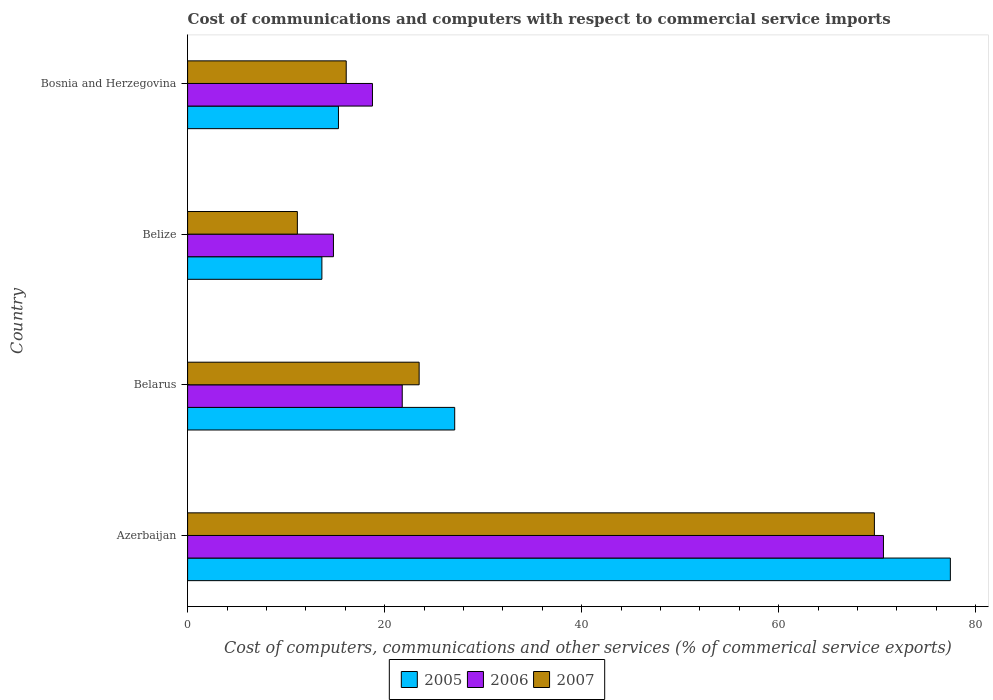How many groups of bars are there?
Give a very brief answer. 4. Are the number of bars on each tick of the Y-axis equal?
Your answer should be compact. Yes. How many bars are there on the 3rd tick from the top?
Provide a short and direct response. 3. How many bars are there on the 4th tick from the bottom?
Make the answer very short. 3. What is the label of the 2nd group of bars from the top?
Give a very brief answer. Belize. In how many cases, is the number of bars for a given country not equal to the number of legend labels?
Offer a very short reply. 0. What is the cost of communications and computers in 2007 in Bosnia and Herzegovina?
Your answer should be compact. 16.1. Across all countries, what is the maximum cost of communications and computers in 2007?
Provide a short and direct response. 69.72. Across all countries, what is the minimum cost of communications and computers in 2005?
Your answer should be very brief. 13.63. In which country was the cost of communications and computers in 2006 maximum?
Provide a short and direct response. Azerbaijan. In which country was the cost of communications and computers in 2005 minimum?
Ensure brevity in your answer.  Belize. What is the total cost of communications and computers in 2007 in the graph?
Provide a succinct answer. 120.46. What is the difference between the cost of communications and computers in 2006 in Belize and that in Bosnia and Herzegovina?
Provide a succinct answer. -3.96. What is the difference between the cost of communications and computers in 2007 in Belize and the cost of communications and computers in 2006 in Belarus?
Provide a succinct answer. -10.65. What is the average cost of communications and computers in 2007 per country?
Your answer should be compact. 30.12. What is the difference between the cost of communications and computers in 2005 and cost of communications and computers in 2006 in Azerbaijan?
Provide a short and direct response. 6.79. In how many countries, is the cost of communications and computers in 2005 greater than 36 %?
Keep it short and to the point. 1. What is the ratio of the cost of communications and computers in 2005 in Azerbaijan to that in Belarus?
Your answer should be compact. 2.86. Is the cost of communications and computers in 2007 in Azerbaijan less than that in Bosnia and Herzegovina?
Provide a succinct answer. No. Is the difference between the cost of communications and computers in 2005 in Belarus and Belize greater than the difference between the cost of communications and computers in 2006 in Belarus and Belize?
Make the answer very short. Yes. What is the difference between the highest and the second highest cost of communications and computers in 2005?
Ensure brevity in your answer.  50.31. What is the difference between the highest and the lowest cost of communications and computers in 2005?
Offer a terse response. 63.8. In how many countries, is the cost of communications and computers in 2005 greater than the average cost of communications and computers in 2005 taken over all countries?
Your response must be concise. 1. Is the sum of the cost of communications and computers in 2006 in Belize and Bosnia and Herzegovina greater than the maximum cost of communications and computers in 2007 across all countries?
Provide a short and direct response. No. What does the 3rd bar from the bottom in Azerbaijan represents?
Provide a short and direct response. 2007. Is it the case that in every country, the sum of the cost of communications and computers in 2005 and cost of communications and computers in 2006 is greater than the cost of communications and computers in 2007?
Provide a succinct answer. Yes. How many bars are there?
Your answer should be very brief. 12. Are the values on the major ticks of X-axis written in scientific E-notation?
Make the answer very short. No. Does the graph contain any zero values?
Ensure brevity in your answer.  No. Does the graph contain grids?
Your answer should be very brief. No. Where does the legend appear in the graph?
Give a very brief answer. Bottom center. What is the title of the graph?
Ensure brevity in your answer.  Cost of communications and computers with respect to commercial service imports. Does "2009" appear as one of the legend labels in the graph?
Give a very brief answer. No. What is the label or title of the X-axis?
Provide a short and direct response. Cost of computers, communications and other services (% of commerical service exports). What is the Cost of computers, communications and other services (% of commerical service exports) in 2005 in Azerbaijan?
Keep it short and to the point. 77.43. What is the Cost of computers, communications and other services (% of commerical service exports) in 2006 in Azerbaijan?
Your response must be concise. 70.64. What is the Cost of computers, communications and other services (% of commerical service exports) in 2007 in Azerbaijan?
Make the answer very short. 69.72. What is the Cost of computers, communications and other services (% of commerical service exports) in 2005 in Belarus?
Offer a very short reply. 27.11. What is the Cost of computers, communications and other services (% of commerical service exports) of 2006 in Belarus?
Your answer should be very brief. 21.79. What is the Cost of computers, communications and other services (% of commerical service exports) in 2007 in Belarus?
Ensure brevity in your answer.  23.5. What is the Cost of computers, communications and other services (% of commerical service exports) in 2005 in Belize?
Offer a terse response. 13.63. What is the Cost of computers, communications and other services (% of commerical service exports) of 2006 in Belize?
Offer a very short reply. 14.8. What is the Cost of computers, communications and other services (% of commerical service exports) of 2007 in Belize?
Your response must be concise. 11.14. What is the Cost of computers, communications and other services (% of commerical service exports) of 2005 in Bosnia and Herzegovina?
Keep it short and to the point. 15.31. What is the Cost of computers, communications and other services (% of commerical service exports) of 2006 in Bosnia and Herzegovina?
Ensure brevity in your answer.  18.76. What is the Cost of computers, communications and other services (% of commerical service exports) of 2007 in Bosnia and Herzegovina?
Give a very brief answer. 16.1. Across all countries, what is the maximum Cost of computers, communications and other services (% of commerical service exports) of 2005?
Keep it short and to the point. 77.43. Across all countries, what is the maximum Cost of computers, communications and other services (% of commerical service exports) of 2006?
Ensure brevity in your answer.  70.64. Across all countries, what is the maximum Cost of computers, communications and other services (% of commerical service exports) of 2007?
Offer a very short reply. 69.72. Across all countries, what is the minimum Cost of computers, communications and other services (% of commerical service exports) of 2005?
Your response must be concise. 13.63. Across all countries, what is the minimum Cost of computers, communications and other services (% of commerical service exports) in 2006?
Give a very brief answer. 14.8. Across all countries, what is the minimum Cost of computers, communications and other services (% of commerical service exports) in 2007?
Ensure brevity in your answer.  11.14. What is the total Cost of computers, communications and other services (% of commerical service exports) in 2005 in the graph?
Offer a very short reply. 133.49. What is the total Cost of computers, communications and other services (% of commerical service exports) in 2006 in the graph?
Offer a terse response. 125.99. What is the total Cost of computers, communications and other services (% of commerical service exports) in 2007 in the graph?
Offer a very short reply. 120.46. What is the difference between the Cost of computers, communications and other services (% of commerical service exports) in 2005 in Azerbaijan and that in Belarus?
Provide a succinct answer. 50.31. What is the difference between the Cost of computers, communications and other services (% of commerical service exports) in 2006 in Azerbaijan and that in Belarus?
Give a very brief answer. 48.85. What is the difference between the Cost of computers, communications and other services (% of commerical service exports) in 2007 in Azerbaijan and that in Belarus?
Make the answer very short. 46.21. What is the difference between the Cost of computers, communications and other services (% of commerical service exports) of 2005 in Azerbaijan and that in Belize?
Provide a short and direct response. 63.8. What is the difference between the Cost of computers, communications and other services (% of commerical service exports) of 2006 in Azerbaijan and that in Belize?
Provide a short and direct response. 55.83. What is the difference between the Cost of computers, communications and other services (% of commerical service exports) of 2007 in Azerbaijan and that in Belize?
Provide a short and direct response. 58.57. What is the difference between the Cost of computers, communications and other services (% of commerical service exports) in 2005 in Azerbaijan and that in Bosnia and Herzegovina?
Your response must be concise. 62.11. What is the difference between the Cost of computers, communications and other services (% of commerical service exports) in 2006 in Azerbaijan and that in Bosnia and Herzegovina?
Give a very brief answer. 51.87. What is the difference between the Cost of computers, communications and other services (% of commerical service exports) in 2007 in Azerbaijan and that in Bosnia and Herzegovina?
Keep it short and to the point. 53.61. What is the difference between the Cost of computers, communications and other services (% of commerical service exports) in 2005 in Belarus and that in Belize?
Provide a short and direct response. 13.48. What is the difference between the Cost of computers, communications and other services (% of commerical service exports) of 2006 in Belarus and that in Belize?
Your response must be concise. 6.98. What is the difference between the Cost of computers, communications and other services (% of commerical service exports) in 2007 in Belarus and that in Belize?
Keep it short and to the point. 12.36. What is the difference between the Cost of computers, communications and other services (% of commerical service exports) of 2005 in Belarus and that in Bosnia and Herzegovina?
Make the answer very short. 11.8. What is the difference between the Cost of computers, communications and other services (% of commerical service exports) of 2006 in Belarus and that in Bosnia and Herzegovina?
Your response must be concise. 3.02. What is the difference between the Cost of computers, communications and other services (% of commerical service exports) in 2007 in Belarus and that in Bosnia and Herzegovina?
Provide a succinct answer. 7.4. What is the difference between the Cost of computers, communications and other services (% of commerical service exports) of 2005 in Belize and that in Bosnia and Herzegovina?
Give a very brief answer. -1.68. What is the difference between the Cost of computers, communications and other services (% of commerical service exports) of 2006 in Belize and that in Bosnia and Herzegovina?
Make the answer very short. -3.96. What is the difference between the Cost of computers, communications and other services (% of commerical service exports) in 2007 in Belize and that in Bosnia and Herzegovina?
Your answer should be very brief. -4.96. What is the difference between the Cost of computers, communications and other services (% of commerical service exports) in 2005 in Azerbaijan and the Cost of computers, communications and other services (% of commerical service exports) in 2006 in Belarus?
Your answer should be compact. 55.64. What is the difference between the Cost of computers, communications and other services (% of commerical service exports) of 2005 in Azerbaijan and the Cost of computers, communications and other services (% of commerical service exports) of 2007 in Belarus?
Keep it short and to the point. 53.92. What is the difference between the Cost of computers, communications and other services (% of commerical service exports) of 2006 in Azerbaijan and the Cost of computers, communications and other services (% of commerical service exports) of 2007 in Belarus?
Your answer should be very brief. 47.13. What is the difference between the Cost of computers, communications and other services (% of commerical service exports) in 2005 in Azerbaijan and the Cost of computers, communications and other services (% of commerical service exports) in 2006 in Belize?
Your answer should be compact. 62.62. What is the difference between the Cost of computers, communications and other services (% of commerical service exports) in 2005 in Azerbaijan and the Cost of computers, communications and other services (% of commerical service exports) in 2007 in Belize?
Ensure brevity in your answer.  66.29. What is the difference between the Cost of computers, communications and other services (% of commerical service exports) of 2006 in Azerbaijan and the Cost of computers, communications and other services (% of commerical service exports) of 2007 in Belize?
Ensure brevity in your answer.  59.49. What is the difference between the Cost of computers, communications and other services (% of commerical service exports) of 2005 in Azerbaijan and the Cost of computers, communications and other services (% of commerical service exports) of 2006 in Bosnia and Herzegovina?
Provide a succinct answer. 58.66. What is the difference between the Cost of computers, communications and other services (% of commerical service exports) in 2005 in Azerbaijan and the Cost of computers, communications and other services (% of commerical service exports) in 2007 in Bosnia and Herzegovina?
Provide a succinct answer. 61.33. What is the difference between the Cost of computers, communications and other services (% of commerical service exports) of 2006 in Azerbaijan and the Cost of computers, communications and other services (% of commerical service exports) of 2007 in Bosnia and Herzegovina?
Offer a very short reply. 54.53. What is the difference between the Cost of computers, communications and other services (% of commerical service exports) of 2005 in Belarus and the Cost of computers, communications and other services (% of commerical service exports) of 2006 in Belize?
Give a very brief answer. 12.31. What is the difference between the Cost of computers, communications and other services (% of commerical service exports) in 2005 in Belarus and the Cost of computers, communications and other services (% of commerical service exports) in 2007 in Belize?
Provide a short and direct response. 15.97. What is the difference between the Cost of computers, communications and other services (% of commerical service exports) in 2006 in Belarus and the Cost of computers, communications and other services (% of commerical service exports) in 2007 in Belize?
Offer a very short reply. 10.65. What is the difference between the Cost of computers, communications and other services (% of commerical service exports) of 2005 in Belarus and the Cost of computers, communications and other services (% of commerical service exports) of 2006 in Bosnia and Herzegovina?
Offer a terse response. 8.35. What is the difference between the Cost of computers, communications and other services (% of commerical service exports) of 2005 in Belarus and the Cost of computers, communications and other services (% of commerical service exports) of 2007 in Bosnia and Herzegovina?
Your answer should be very brief. 11.01. What is the difference between the Cost of computers, communications and other services (% of commerical service exports) of 2006 in Belarus and the Cost of computers, communications and other services (% of commerical service exports) of 2007 in Bosnia and Herzegovina?
Make the answer very short. 5.69. What is the difference between the Cost of computers, communications and other services (% of commerical service exports) of 2005 in Belize and the Cost of computers, communications and other services (% of commerical service exports) of 2006 in Bosnia and Herzegovina?
Make the answer very short. -5.13. What is the difference between the Cost of computers, communications and other services (% of commerical service exports) in 2005 in Belize and the Cost of computers, communications and other services (% of commerical service exports) in 2007 in Bosnia and Herzegovina?
Ensure brevity in your answer.  -2.47. What is the difference between the Cost of computers, communications and other services (% of commerical service exports) of 2006 in Belize and the Cost of computers, communications and other services (% of commerical service exports) of 2007 in Bosnia and Herzegovina?
Give a very brief answer. -1.3. What is the average Cost of computers, communications and other services (% of commerical service exports) in 2005 per country?
Keep it short and to the point. 33.37. What is the average Cost of computers, communications and other services (% of commerical service exports) of 2006 per country?
Your answer should be compact. 31.5. What is the average Cost of computers, communications and other services (% of commerical service exports) of 2007 per country?
Keep it short and to the point. 30.12. What is the difference between the Cost of computers, communications and other services (% of commerical service exports) of 2005 and Cost of computers, communications and other services (% of commerical service exports) of 2006 in Azerbaijan?
Make the answer very short. 6.79. What is the difference between the Cost of computers, communications and other services (% of commerical service exports) in 2005 and Cost of computers, communications and other services (% of commerical service exports) in 2007 in Azerbaijan?
Offer a terse response. 7.71. What is the difference between the Cost of computers, communications and other services (% of commerical service exports) in 2006 and Cost of computers, communications and other services (% of commerical service exports) in 2007 in Azerbaijan?
Offer a terse response. 0.92. What is the difference between the Cost of computers, communications and other services (% of commerical service exports) in 2005 and Cost of computers, communications and other services (% of commerical service exports) in 2006 in Belarus?
Your answer should be compact. 5.33. What is the difference between the Cost of computers, communications and other services (% of commerical service exports) of 2005 and Cost of computers, communications and other services (% of commerical service exports) of 2007 in Belarus?
Your response must be concise. 3.61. What is the difference between the Cost of computers, communications and other services (% of commerical service exports) of 2006 and Cost of computers, communications and other services (% of commerical service exports) of 2007 in Belarus?
Give a very brief answer. -1.72. What is the difference between the Cost of computers, communications and other services (% of commerical service exports) of 2005 and Cost of computers, communications and other services (% of commerical service exports) of 2006 in Belize?
Your answer should be compact. -1.17. What is the difference between the Cost of computers, communications and other services (% of commerical service exports) of 2005 and Cost of computers, communications and other services (% of commerical service exports) of 2007 in Belize?
Ensure brevity in your answer.  2.49. What is the difference between the Cost of computers, communications and other services (% of commerical service exports) of 2006 and Cost of computers, communications and other services (% of commerical service exports) of 2007 in Belize?
Offer a very short reply. 3.66. What is the difference between the Cost of computers, communications and other services (% of commerical service exports) in 2005 and Cost of computers, communications and other services (% of commerical service exports) in 2006 in Bosnia and Herzegovina?
Provide a succinct answer. -3.45. What is the difference between the Cost of computers, communications and other services (% of commerical service exports) in 2005 and Cost of computers, communications and other services (% of commerical service exports) in 2007 in Bosnia and Herzegovina?
Offer a terse response. -0.79. What is the difference between the Cost of computers, communications and other services (% of commerical service exports) in 2006 and Cost of computers, communications and other services (% of commerical service exports) in 2007 in Bosnia and Herzegovina?
Your answer should be very brief. 2.66. What is the ratio of the Cost of computers, communications and other services (% of commerical service exports) of 2005 in Azerbaijan to that in Belarus?
Ensure brevity in your answer.  2.86. What is the ratio of the Cost of computers, communications and other services (% of commerical service exports) of 2006 in Azerbaijan to that in Belarus?
Your answer should be very brief. 3.24. What is the ratio of the Cost of computers, communications and other services (% of commerical service exports) in 2007 in Azerbaijan to that in Belarus?
Your response must be concise. 2.97. What is the ratio of the Cost of computers, communications and other services (% of commerical service exports) of 2005 in Azerbaijan to that in Belize?
Your answer should be compact. 5.68. What is the ratio of the Cost of computers, communications and other services (% of commerical service exports) in 2006 in Azerbaijan to that in Belize?
Keep it short and to the point. 4.77. What is the ratio of the Cost of computers, communications and other services (% of commerical service exports) of 2007 in Azerbaijan to that in Belize?
Your answer should be compact. 6.26. What is the ratio of the Cost of computers, communications and other services (% of commerical service exports) of 2005 in Azerbaijan to that in Bosnia and Herzegovina?
Give a very brief answer. 5.06. What is the ratio of the Cost of computers, communications and other services (% of commerical service exports) of 2006 in Azerbaijan to that in Bosnia and Herzegovina?
Provide a succinct answer. 3.76. What is the ratio of the Cost of computers, communications and other services (% of commerical service exports) of 2007 in Azerbaijan to that in Bosnia and Herzegovina?
Your answer should be very brief. 4.33. What is the ratio of the Cost of computers, communications and other services (% of commerical service exports) in 2005 in Belarus to that in Belize?
Your answer should be very brief. 1.99. What is the ratio of the Cost of computers, communications and other services (% of commerical service exports) in 2006 in Belarus to that in Belize?
Give a very brief answer. 1.47. What is the ratio of the Cost of computers, communications and other services (% of commerical service exports) in 2007 in Belarus to that in Belize?
Give a very brief answer. 2.11. What is the ratio of the Cost of computers, communications and other services (% of commerical service exports) of 2005 in Belarus to that in Bosnia and Herzegovina?
Offer a very short reply. 1.77. What is the ratio of the Cost of computers, communications and other services (% of commerical service exports) of 2006 in Belarus to that in Bosnia and Herzegovina?
Your answer should be very brief. 1.16. What is the ratio of the Cost of computers, communications and other services (% of commerical service exports) in 2007 in Belarus to that in Bosnia and Herzegovina?
Make the answer very short. 1.46. What is the ratio of the Cost of computers, communications and other services (% of commerical service exports) of 2005 in Belize to that in Bosnia and Herzegovina?
Keep it short and to the point. 0.89. What is the ratio of the Cost of computers, communications and other services (% of commerical service exports) of 2006 in Belize to that in Bosnia and Herzegovina?
Offer a very short reply. 0.79. What is the ratio of the Cost of computers, communications and other services (% of commerical service exports) of 2007 in Belize to that in Bosnia and Herzegovina?
Offer a terse response. 0.69. What is the difference between the highest and the second highest Cost of computers, communications and other services (% of commerical service exports) in 2005?
Keep it short and to the point. 50.31. What is the difference between the highest and the second highest Cost of computers, communications and other services (% of commerical service exports) of 2006?
Ensure brevity in your answer.  48.85. What is the difference between the highest and the second highest Cost of computers, communications and other services (% of commerical service exports) of 2007?
Provide a short and direct response. 46.21. What is the difference between the highest and the lowest Cost of computers, communications and other services (% of commerical service exports) of 2005?
Provide a short and direct response. 63.8. What is the difference between the highest and the lowest Cost of computers, communications and other services (% of commerical service exports) of 2006?
Offer a terse response. 55.83. What is the difference between the highest and the lowest Cost of computers, communications and other services (% of commerical service exports) of 2007?
Make the answer very short. 58.57. 